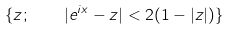Convert formula to latex. <formula><loc_0><loc_0><loc_500><loc_500>\{ z ; \quad | e ^ { i x } - z | < 2 ( 1 - | z | ) \}</formula> 